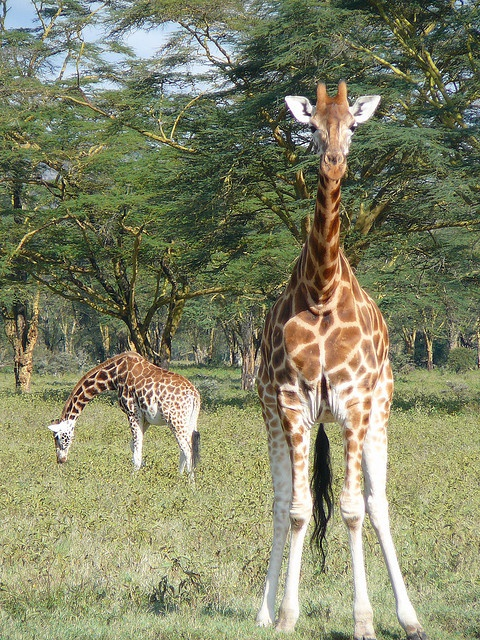Describe the objects in this image and their specific colors. I can see giraffe in teal, ivory, darkgray, gray, and tan tones and giraffe in teal, ivory, gray, and tan tones in this image. 